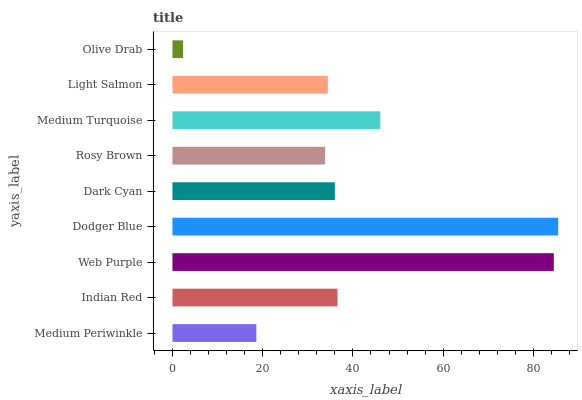Is Olive Drab the minimum?
Answer yes or no. Yes. Is Dodger Blue the maximum?
Answer yes or no. Yes. Is Indian Red the minimum?
Answer yes or no. No. Is Indian Red the maximum?
Answer yes or no. No. Is Indian Red greater than Medium Periwinkle?
Answer yes or no. Yes. Is Medium Periwinkle less than Indian Red?
Answer yes or no. Yes. Is Medium Periwinkle greater than Indian Red?
Answer yes or no. No. Is Indian Red less than Medium Periwinkle?
Answer yes or no. No. Is Dark Cyan the high median?
Answer yes or no. Yes. Is Dark Cyan the low median?
Answer yes or no. Yes. Is Medium Turquoise the high median?
Answer yes or no. No. Is Olive Drab the low median?
Answer yes or no. No. 